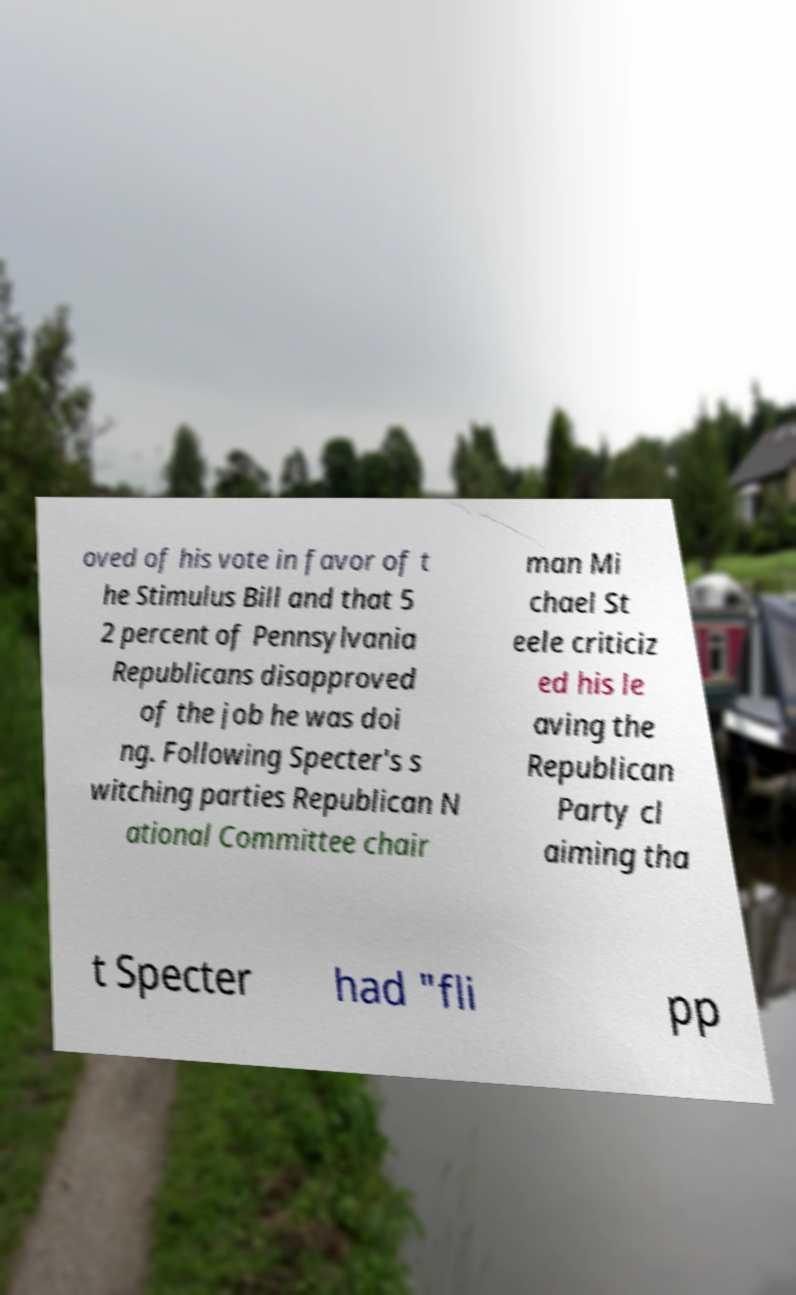Please identify and transcribe the text found in this image. oved of his vote in favor of t he Stimulus Bill and that 5 2 percent of Pennsylvania Republicans disapproved of the job he was doi ng. Following Specter's s witching parties Republican N ational Committee chair man Mi chael St eele criticiz ed his le aving the Republican Party cl aiming tha t Specter had "fli pp 